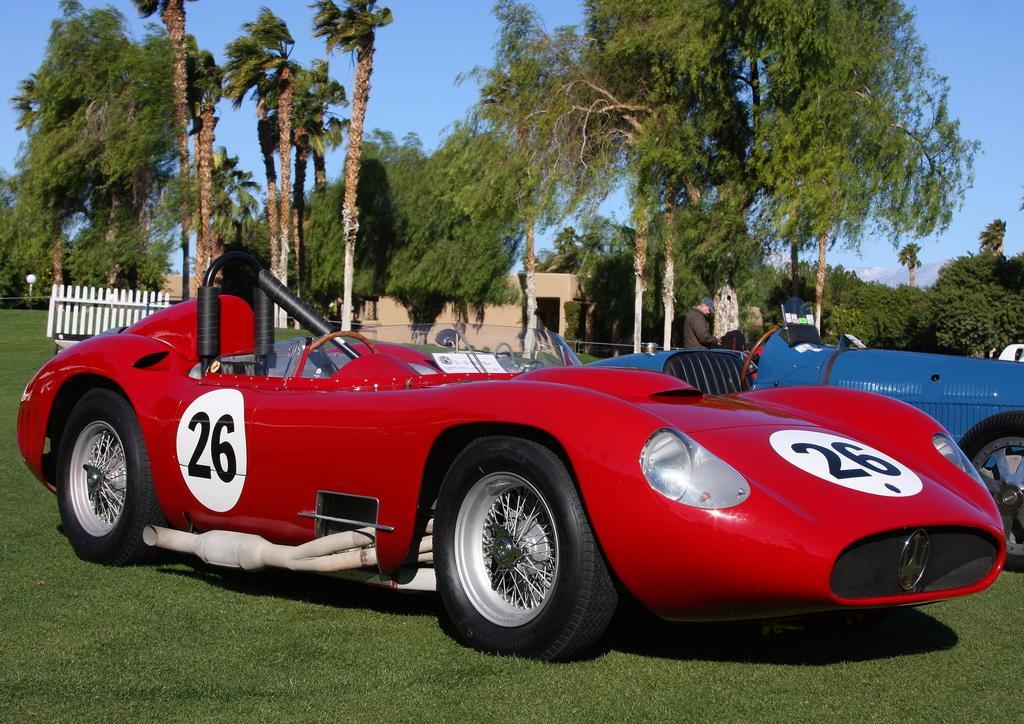Describe this image in one or two sentences. We can see vehicles on the grass. There is a person standing. On the background we can see trees,sky,house,fence,light. 